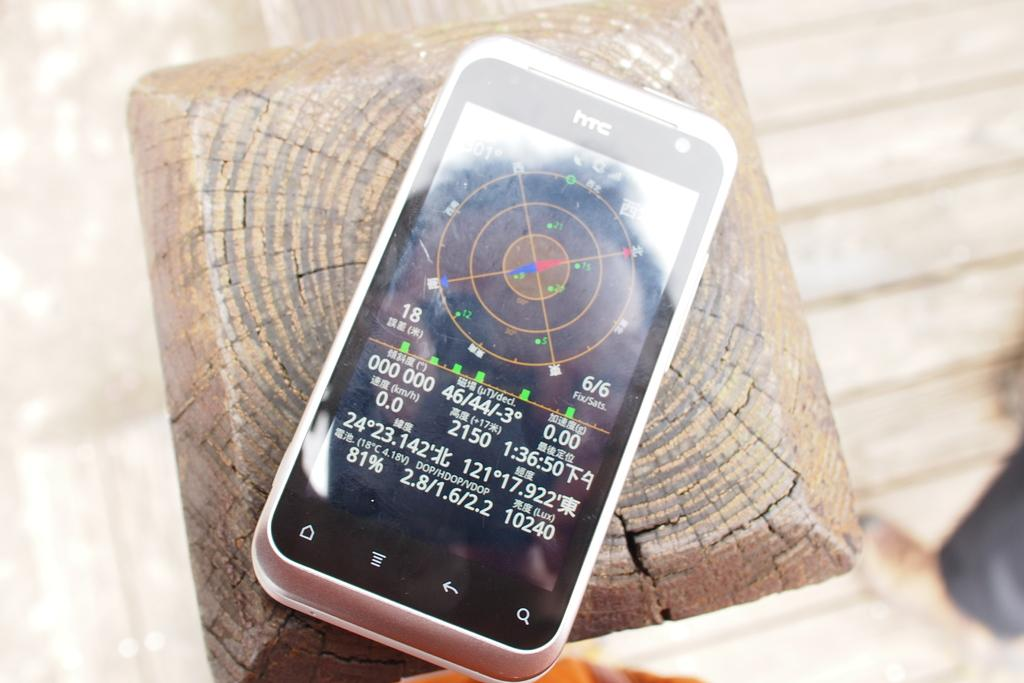Provide a one-sentence caption for the provided image. a black and white htc phone with numbers like 46/44 on the screen. 